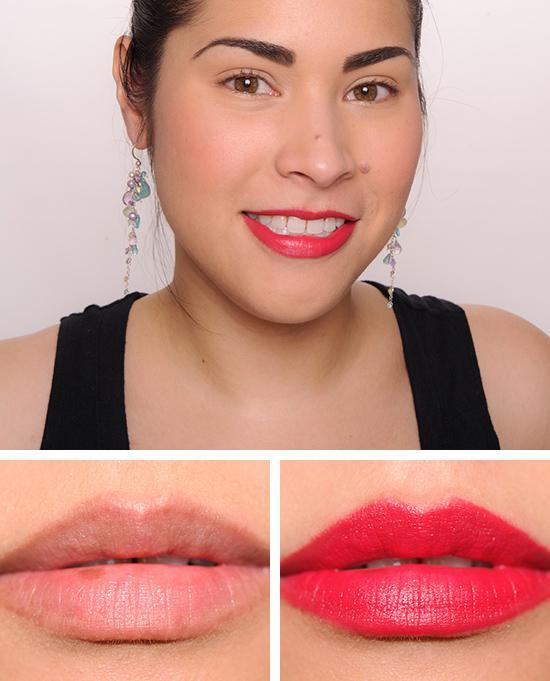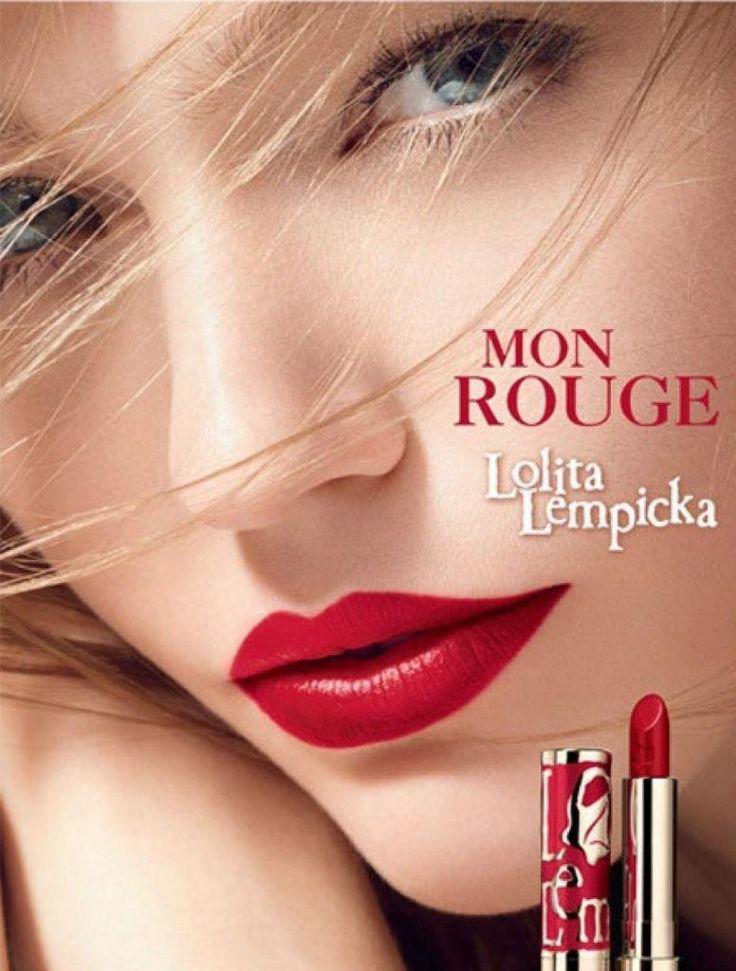The first image is the image on the left, the second image is the image on the right. For the images shown, is this caption "The right image contains a human wearing a large necklace." true? Answer yes or no. No. The first image is the image on the left, the second image is the image on the right. Assess this claim about the two images: "An image shows untinted and tinted lips under the face of a smiling model.". Correct or not? Answer yes or no. Yes. 